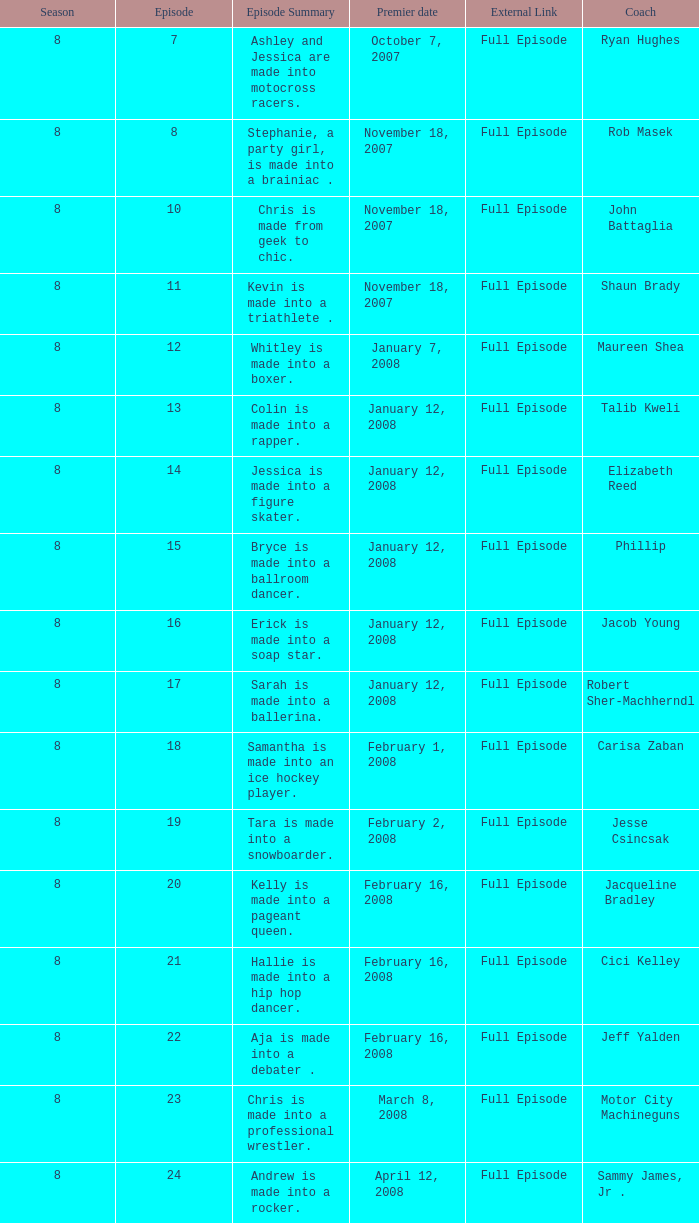Who was the coach for episode 15? Phillip. I'm looking to parse the entire table for insights. Could you assist me with that? {'header': ['Season', 'Episode', 'Episode Summary', 'Premier date', 'External Link', 'Coach'], 'rows': [['8', '7', 'Ashley and Jessica are made into motocross racers.', 'October 7, 2007', 'Full Episode', 'Ryan Hughes'], ['8', '8', 'Stephanie, a party girl, is made into a brainiac .', 'November 18, 2007', 'Full Episode', 'Rob Masek'], ['8', '10', 'Chris is made from geek to chic.', 'November 18, 2007', 'Full Episode', 'John Battaglia'], ['8', '11', 'Kevin is made into a triathlete .', 'November 18, 2007', 'Full Episode', 'Shaun Brady'], ['8', '12', 'Whitley is made into a boxer.', 'January 7, 2008', 'Full Episode', 'Maureen Shea'], ['8', '13', 'Colin is made into a rapper.', 'January 12, 2008', 'Full Episode', 'Talib Kweli'], ['8', '14', 'Jessica is made into a figure skater.', 'January 12, 2008', 'Full Episode', 'Elizabeth Reed'], ['8', '15', 'Bryce is made into a ballroom dancer.', 'January 12, 2008', 'Full Episode', 'Phillip'], ['8', '16', 'Erick is made into a soap star.', 'January 12, 2008', 'Full Episode', 'Jacob Young'], ['8', '17', 'Sarah is made into a ballerina.', 'January 12, 2008', 'Full Episode', 'Robert Sher-Machherndl'], ['8', '18', 'Samantha is made into an ice hockey player.', 'February 1, 2008', 'Full Episode', 'Carisa Zaban'], ['8', '19', 'Tara is made into a snowboarder.', 'February 2, 2008', 'Full Episode', 'Jesse Csincsak'], ['8', '20', 'Kelly is made into a pageant queen.', 'February 16, 2008', 'Full Episode', 'Jacqueline Bradley'], ['8', '21', 'Hallie is made into a hip hop dancer.', 'February 16, 2008', 'Full Episode', 'Cici Kelley'], ['8', '22', 'Aja is made into a debater .', 'February 16, 2008', 'Full Episode', 'Jeff Yalden'], ['8', '23', 'Chris is made into a professional wrestler.', 'March 8, 2008', 'Full Episode', 'Motor City Machineguns'], ['8', '24', 'Andrew is made into a rocker.', 'April 12, 2008', 'Full Episode', 'Sammy James, Jr .']]} 